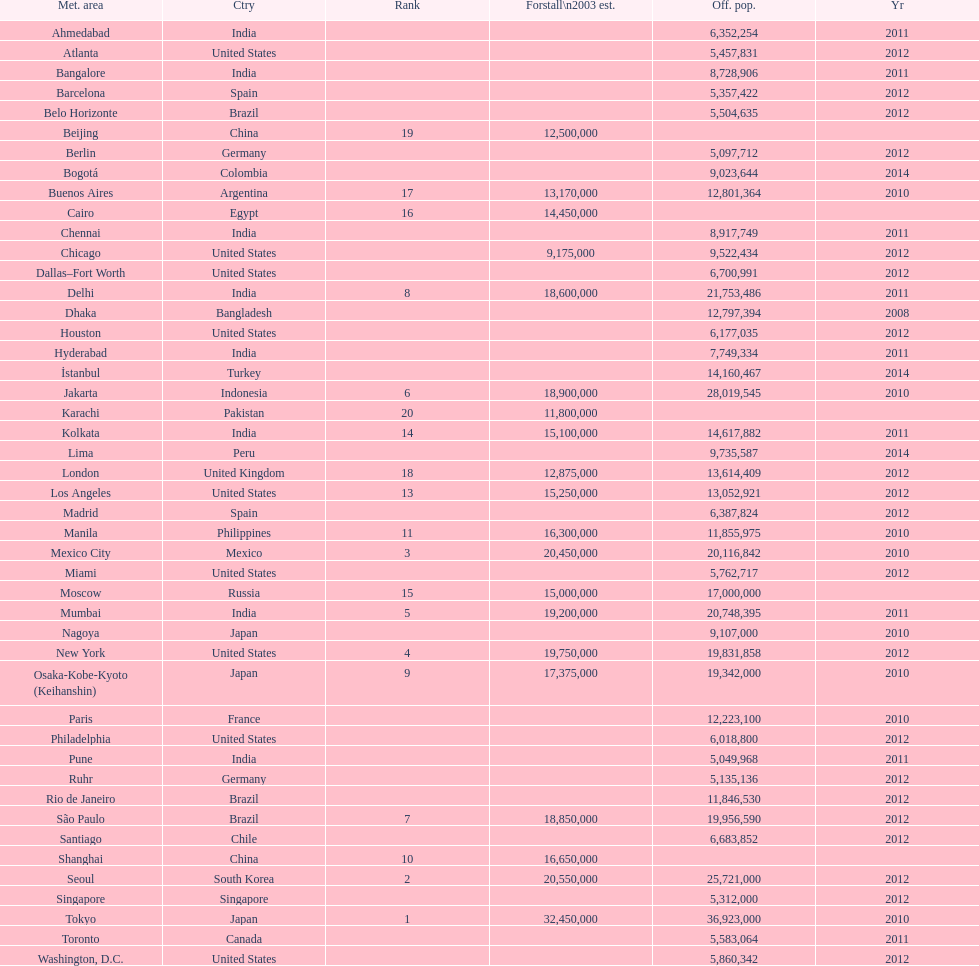Which areas had a population of more than 10,000,000 but less than 20,000,000? Buenos Aires, Dhaka, İstanbul, Kolkata, London, Los Angeles, Manila, Moscow, New York, Osaka-Kobe-Kyoto (Keihanshin), Paris, Rio de Janeiro, São Paulo. 